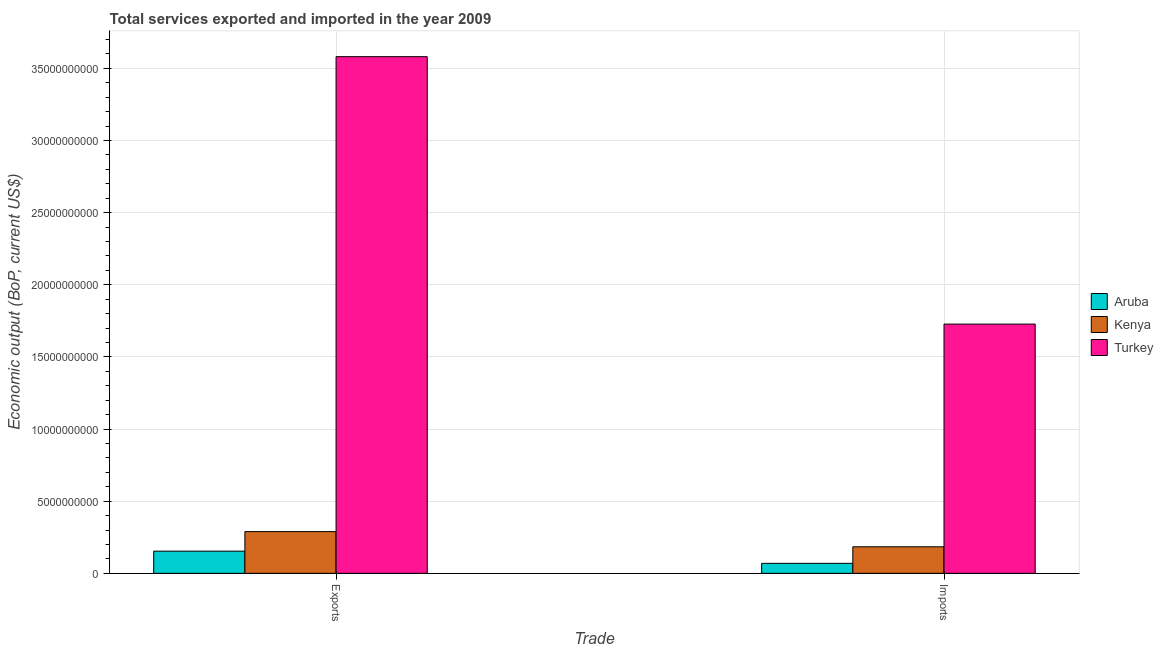How many groups of bars are there?
Your answer should be very brief. 2. Are the number of bars on each tick of the X-axis equal?
Make the answer very short. Yes. How many bars are there on the 1st tick from the right?
Ensure brevity in your answer.  3. What is the label of the 2nd group of bars from the left?
Offer a very short reply. Imports. What is the amount of service imports in Aruba?
Give a very brief answer. 6.93e+08. Across all countries, what is the maximum amount of service exports?
Provide a short and direct response. 3.58e+1. Across all countries, what is the minimum amount of service exports?
Keep it short and to the point. 1.54e+09. In which country was the amount of service exports maximum?
Offer a terse response. Turkey. In which country was the amount of service imports minimum?
Provide a short and direct response. Aruba. What is the total amount of service imports in the graph?
Your response must be concise. 1.98e+1. What is the difference between the amount of service imports in Turkey and that in Aruba?
Keep it short and to the point. 1.66e+1. What is the difference between the amount of service exports in Kenya and the amount of service imports in Aruba?
Your answer should be very brief. 2.20e+09. What is the average amount of service exports per country?
Your response must be concise. 1.34e+1. What is the difference between the amount of service imports and amount of service exports in Kenya?
Your answer should be very brief. -1.05e+09. What is the ratio of the amount of service exports in Turkey to that in Aruba?
Provide a short and direct response. 23.28. Is the amount of service exports in Aruba less than that in Turkey?
Offer a very short reply. Yes. How many countries are there in the graph?
Give a very brief answer. 3. What is the difference between two consecutive major ticks on the Y-axis?
Keep it short and to the point. 5.00e+09. How are the legend labels stacked?
Offer a very short reply. Vertical. What is the title of the graph?
Provide a short and direct response. Total services exported and imported in the year 2009. What is the label or title of the X-axis?
Offer a terse response. Trade. What is the label or title of the Y-axis?
Keep it short and to the point. Economic output (BoP, current US$). What is the Economic output (BoP, current US$) in Aruba in Exports?
Keep it short and to the point. 1.54e+09. What is the Economic output (BoP, current US$) of Kenya in Exports?
Give a very brief answer. 2.89e+09. What is the Economic output (BoP, current US$) of Turkey in Exports?
Your answer should be very brief. 3.58e+1. What is the Economic output (BoP, current US$) of Aruba in Imports?
Offer a very short reply. 6.93e+08. What is the Economic output (BoP, current US$) in Kenya in Imports?
Provide a succinct answer. 1.84e+09. What is the Economic output (BoP, current US$) of Turkey in Imports?
Offer a very short reply. 1.73e+1. Across all Trade, what is the maximum Economic output (BoP, current US$) in Aruba?
Give a very brief answer. 1.54e+09. Across all Trade, what is the maximum Economic output (BoP, current US$) of Kenya?
Provide a short and direct response. 2.89e+09. Across all Trade, what is the maximum Economic output (BoP, current US$) of Turkey?
Make the answer very short. 3.58e+1. Across all Trade, what is the minimum Economic output (BoP, current US$) of Aruba?
Offer a very short reply. 6.93e+08. Across all Trade, what is the minimum Economic output (BoP, current US$) of Kenya?
Ensure brevity in your answer.  1.84e+09. Across all Trade, what is the minimum Economic output (BoP, current US$) in Turkey?
Provide a succinct answer. 1.73e+1. What is the total Economic output (BoP, current US$) in Aruba in the graph?
Offer a very short reply. 2.23e+09. What is the total Economic output (BoP, current US$) in Kenya in the graph?
Offer a terse response. 4.73e+09. What is the total Economic output (BoP, current US$) of Turkey in the graph?
Offer a very short reply. 5.31e+1. What is the difference between the Economic output (BoP, current US$) of Aruba in Exports and that in Imports?
Your response must be concise. 8.46e+08. What is the difference between the Economic output (BoP, current US$) in Kenya in Exports and that in Imports?
Keep it short and to the point. 1.05e+09. What is the difference between the Economic output (BoP, current US$) in Turkey in Exports and that in Imports?
Give a very brief answer. 1.85e+1. What is the difference between the Economic output (BoP, current US$) in Aruba in Exports and the Economic output (BoP, current US$) in Kenya in Imports?
Ensure brevity in your answer.  -3.02e+08. What is the difference between the Economic output (BoP, current US$) of Aruba in Exports and the Economic output (BoP, current US$) of Turkey in Imports?
Offer a very short reply. -1.57e+1. What is the difference between the Economic output (BoP, current US$) in Kenya in Exports and the Economic output (BoP, current US$) in Turkey in Imports?
Your response must be concise. -1.44e+1. What is the average Economic output (BoP, current US$) in Aruba per Trade?
Offer a very short reply. 1.12e+09. What is the average Economic output (BoP, current US$) of Kenya per Trade?
Offer a terse response. 2.37e+09. What is the average Economic output (BoP, current US$) in Turkey per Trade?
Give a very brief answer. 2.65e+1. What is the difference between the Economic output (BoP, current US$) in Aruba and Economic output (BoP, current US$) in Kenya in Exports?
Ensure brevity in your answer.  -1.35e+09. What is the difference between the Economic output (BoP, current US$) of Aruba and Economic output (BoP, current US$) of Turkey in Exports?
Ensure brevity in your answer.  -3.43e+1. What is the difference between the Economic output (BoP, current US$) of Kenya and Economic output (BoP, current US$) of Turkey in Exports?
Provide a succinct answer. -3.29e+1. What is the difference between the Economic output (BoP, current US$) of Aruba and Economic output (BoP, current US$) of Kenya in Imports?
Ensure brevity in your answer.  -1.15e+09. What is the difference between the Economic output (BoP, current US$) in Aruba and Economic output (BoP, current US$) in Turkey in Imports?
Your answer should be compact. -1.66e+1. What is the difference between the Economic output (BoP, current US$) in Kenya and Economic output (BoP, current US$) in Turkey in Imports?
Ensure brevity in your answer.  -1.54e+1. What is the ratio of the Economic output (BoP, current US$) of Aruba in Exports to that in Imports?
Ensure brevity in your answer.  2.22. What is the ratio of the Economic output (BoP, current US$) of Kenya in Exports to that in Imports?
Keep it short and to the point. 1.57. What is the ratio of the Economic output (BoP, current US$) in Turkey in Exports to that in Imports?
Your response must be concise. 2.07. What is the difference between the highest and the second highest Economic output (BoP, current US$) of Aruba?
Provide a short and direct response. 8.46e+08. What is the difference between the highest and the second highest Economic output (BoP, current US$) of Kenya?
Your response must be concise. 1.05e+09. What is the difference between the highest and the second highest Economic output (BoP, current US$) of Turkey?
Keep it short and to the point. 1.85e+1. What is the difference between the highest and the lowest Economic output (BoP, current US$) in Aruba?
Provide a short and direct response. 8.46e+08. What is the difference between the highest and the lowest Economic output (BoP, current US$) of Kenya?
Ensure brevity in your answer.  1.05e+09. What is the difference between the highest and the lowest Economic output (BoP, current US$) in Turkey?
Offer a terse response. 1.85e+1. 